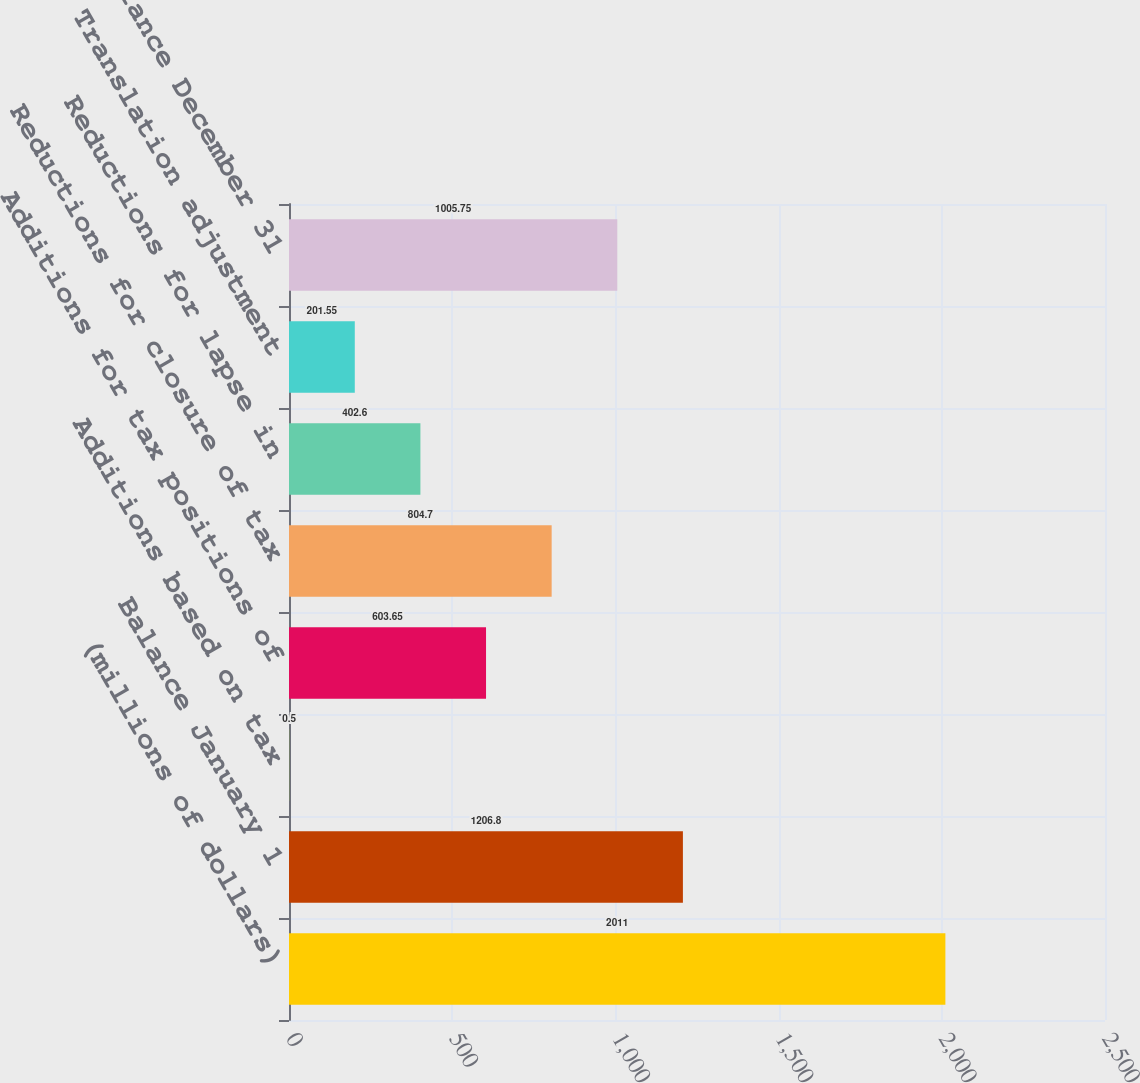<chart> <loc_0><loc_0><loc_500><loc_500><bar_chart><fcel>(millions of dollars)<fcel>Balance January 1<fcel>Additions based on tax<fcel>Additions for tax positions of<fcel>Reductions for closure of tax<fcel>Reductions for lapse in<fcel>Translation adjustment<fcel>Balance December 31<nl><fcel>2011<fcel>1206.8<fcel>0.5<fcel>603.65<fcel>804.7<fcel>402.6<fcel>201.55<fcel>1005.75<nl></chart> 